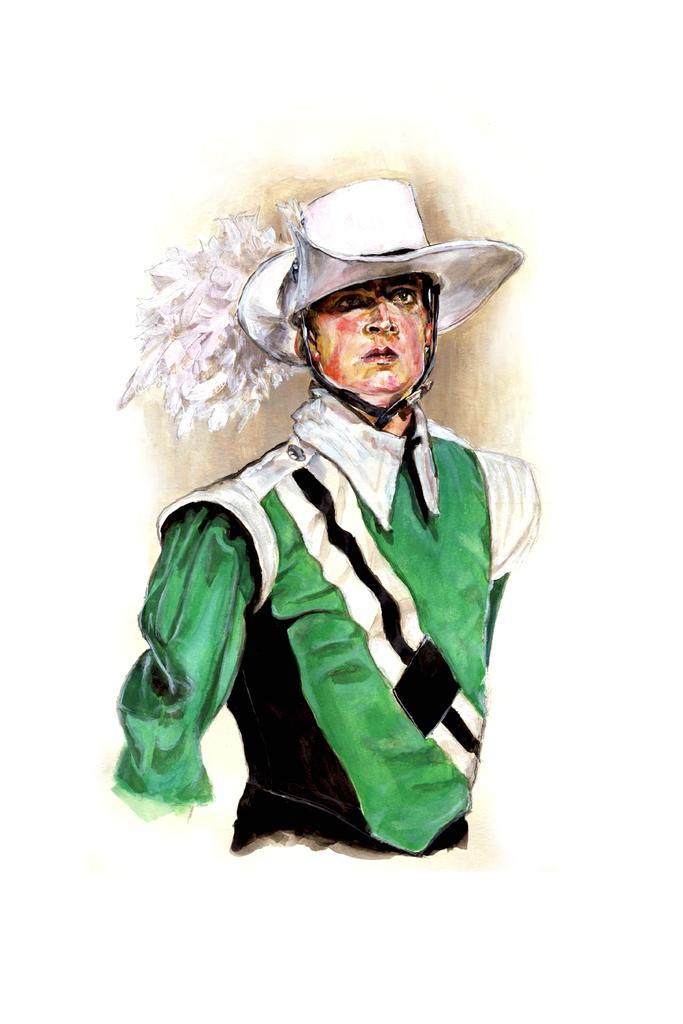What is the main subject of the painting in the image? The main subject of the painting is a man. What is the man wearing on his head? The man is wearing a cap. What color is the background of the painting? The background of the painting is white. What type of pump can be seen in the painting? There is no pump present in the painting; it is a portrait of a man wearing a cap with a white background. 